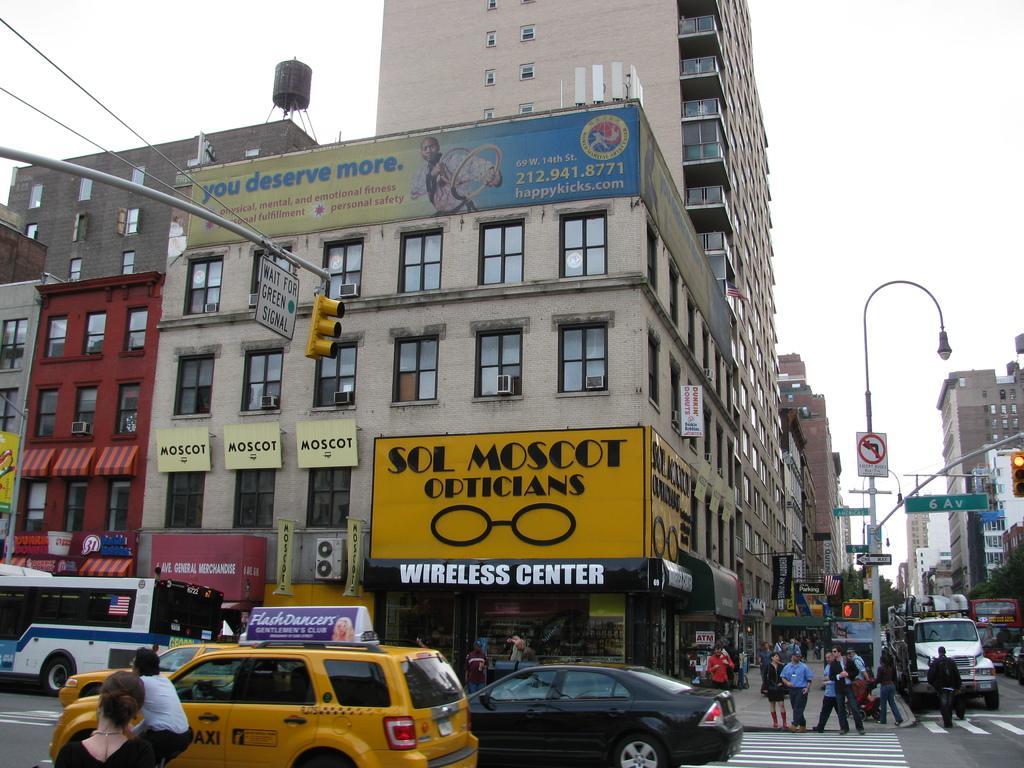Could you give a brief overview of what you see in this image? In this image we can see buildings, boards, pole and lights. At the bottom of the image, we can see vehicles, road, people and pavement. At the top of the image, we can see the sky. 